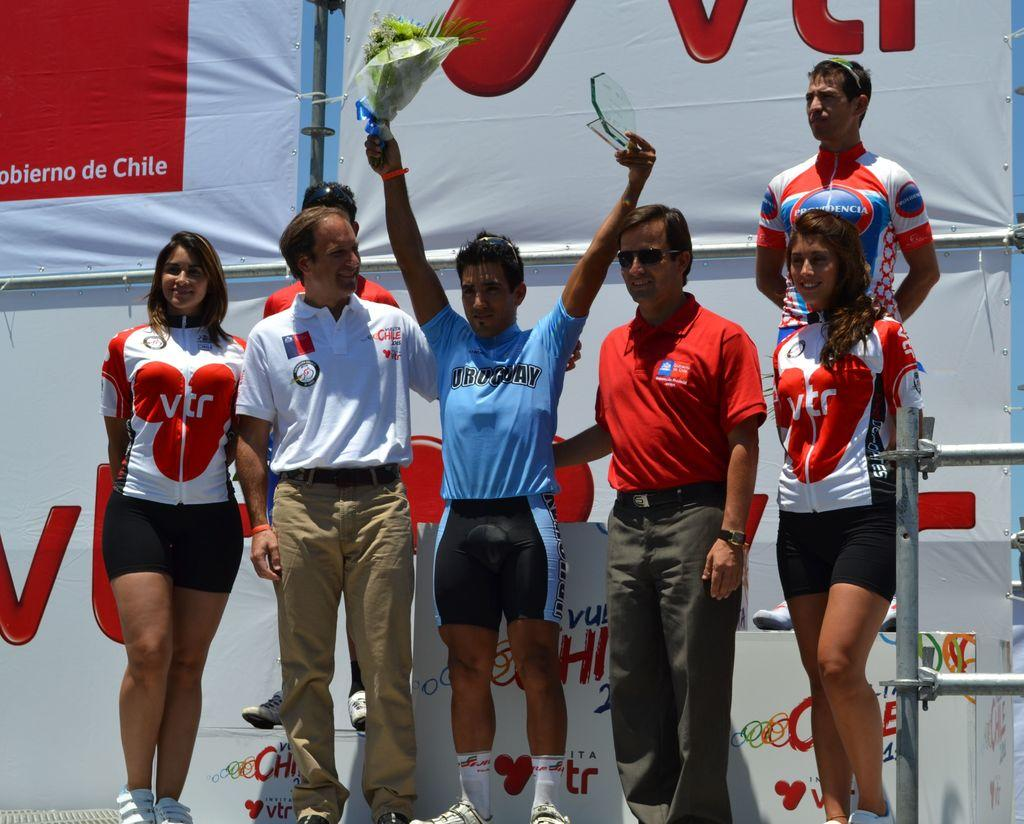<image>
Describe the image concisely. A player in Chile holds up a trophy and flowers while standing with his team VTR. 